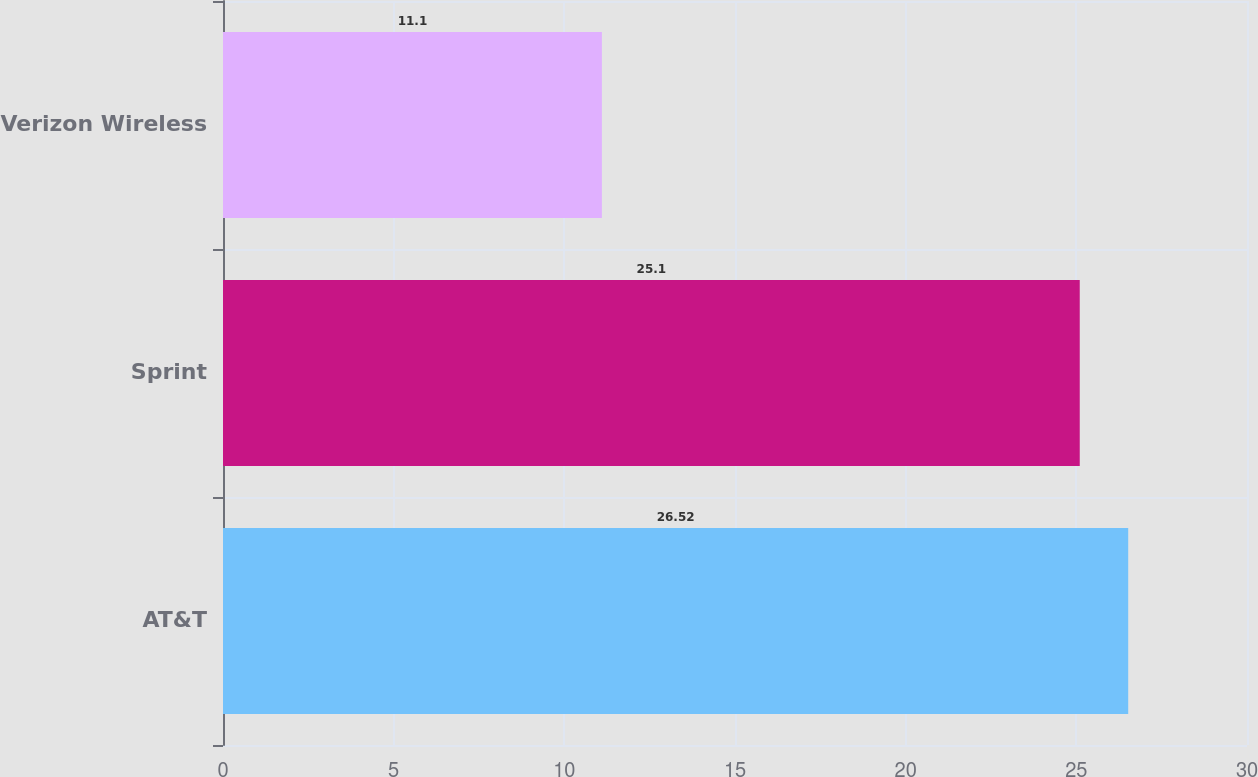Convert chart to OTSL. <chart><loc_0><loc_0><loc_500><loc_500><bar_chart><fcel>AT&T<fcel>Sprint<fcel>Verizon Wireless<nl><fcel>26.52<fcel>25.1<fcel>11.1<nl></chart> 